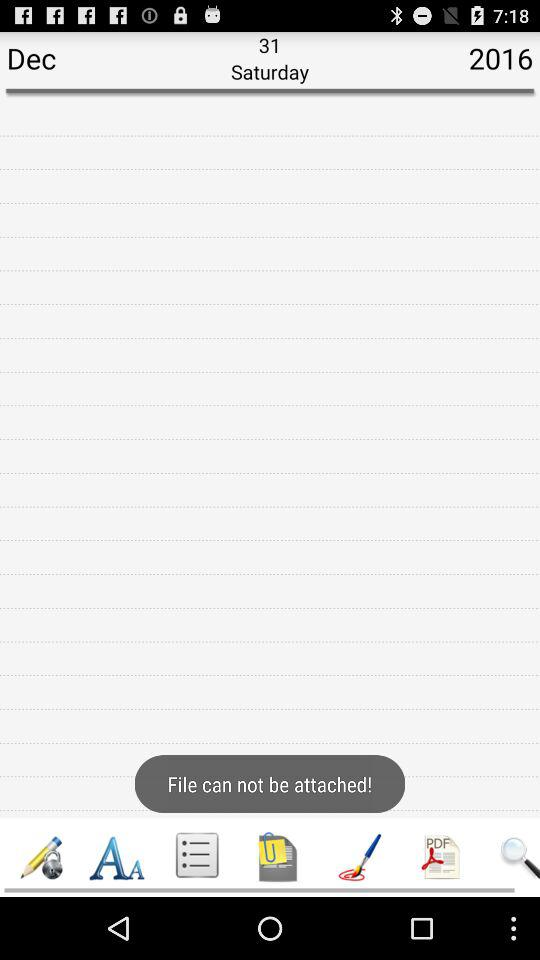Which date is shown on the screen? The date is Saturday, December 31, 2016. 